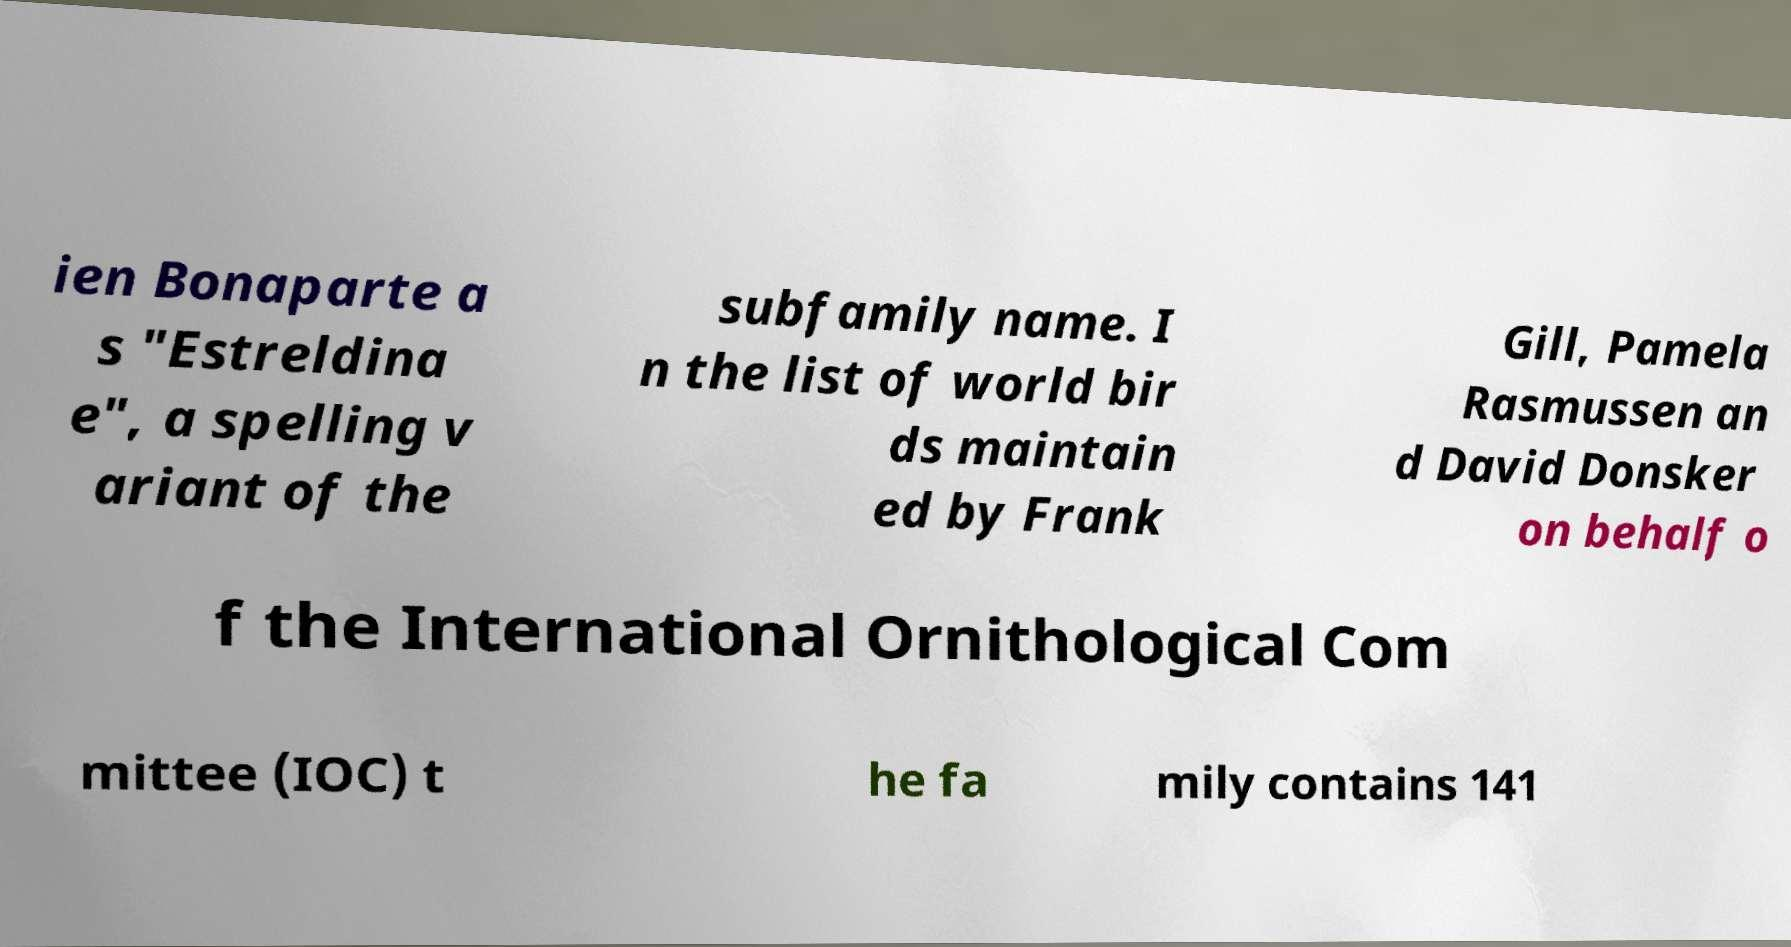What messages or text are displayed in this image? I need them in a readable, typed format. ien Bonaparte a s "Estreldina e", a spelling v ariant of the subfamily name. I n the list of world bir ds maintain ed by Frank Gill, Pamela Rasmussen an d David Donsker on behalf o f the International Ornithological Com mittee (IOC) t he fa mily contains 141 